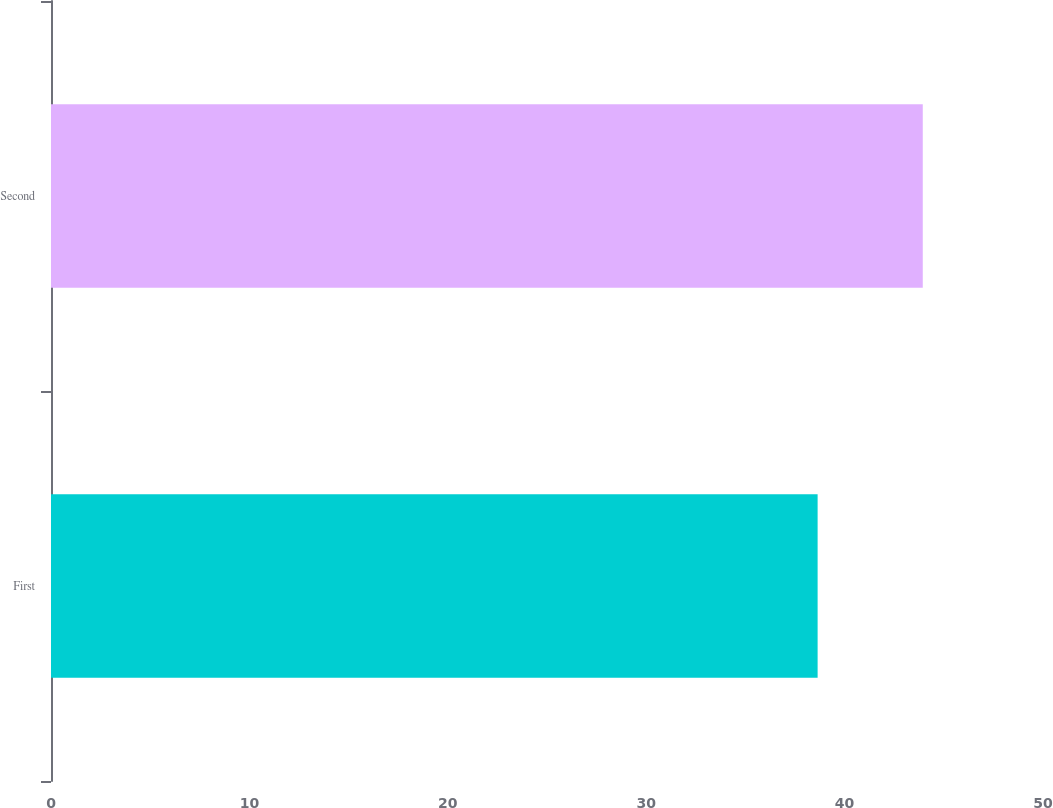<chart> <loc_0><loc_0><loc_500><loc_500><bar_chart><fcel>First<fcel>Second<nl><fcel>38.64<fcel>43.94<nl></chart> 